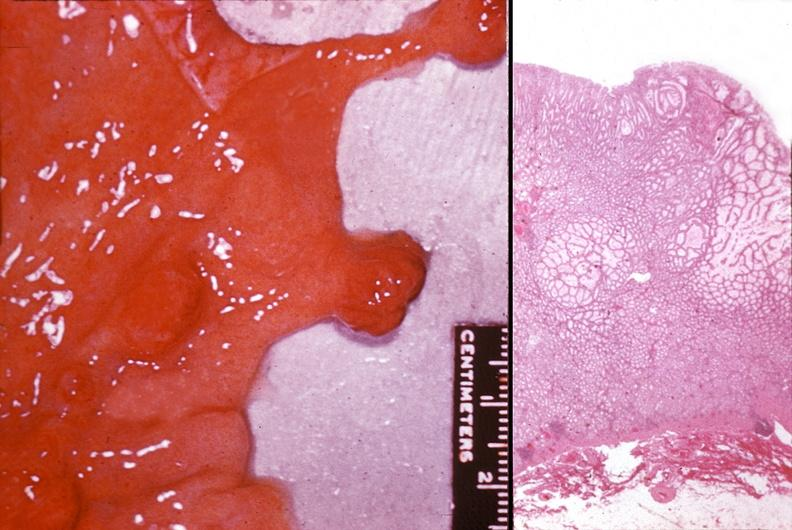where does this belong to?
Answer the question using a single word or phrase. Gastrointestinal system 